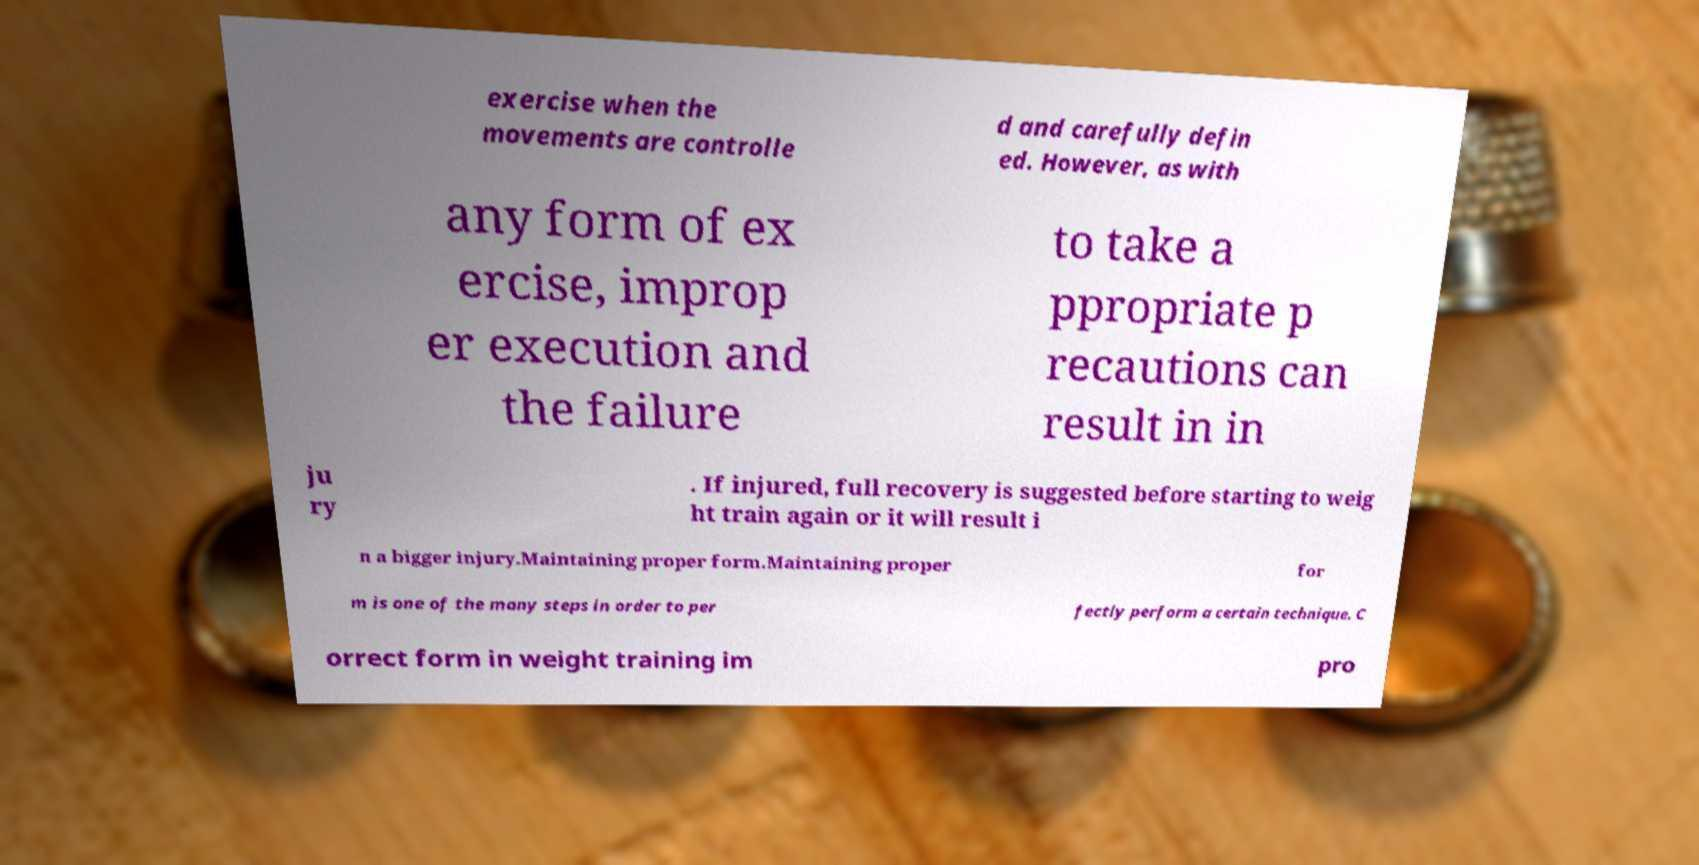Can you accurately transcribe the text from the provided image for me? exercise when the movements are controlle d and carefully defin ed. However, as with any form of ex ercise, improp er execution and the failure to take a ppropriate p recautions can result in in ju ry . If injured, full recovery is suggested before starting to weig ht train again or it will result i n a bigger injury.Maintaining proper form.Maintaining proper for m is one of the many steps in order to per fectly perform a certain technique. C orrect form in weight training im pro 